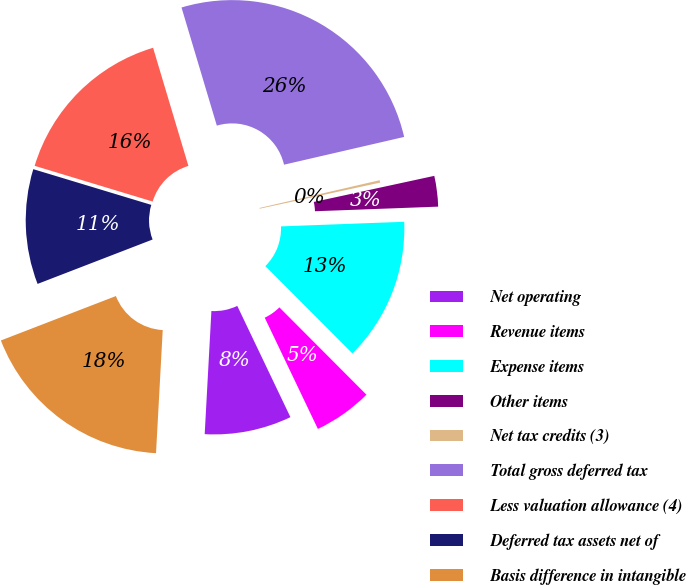Convert chart to OTSL. <chart><loc_0><loc_0><loc_500><loc_500><pie_chart><fcel>Net operating<fcel>Revenue items<fcel>Expense items<fcel>Other items<fcel>Net tax credits (3)<fcel>Total gross deferred tax<fcel>Less valuation allowance (4)<fcel>Deferred tax assets net of<fcel>Basis difference in intangible<nl><fcel>7.96%<fcel>5.38%<fcel>13.12%<fcel>2.8%<fcel>0.22%<fcel>26.01%<fcel>15.7%<fcel>10.54%<fcel>18.27%<nl></chart> 